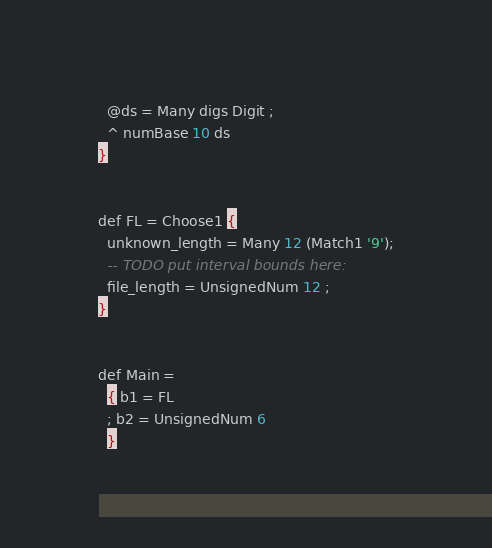<code> <loc_0><loc_0><loc_500><loc_500><_SQL_>  @ds = Many digs Digit ;
  ^ numBase 10 ds
}


def FL = Choose1 {
  unknown_length = Many 12 (Match1 '9');
  -- TODO put interval bounds here:
  file_length = UnsignedNum 12 ;
}


def Main =
  { b1 = FL
  ; b2 = UnsignedNum 6
  }
</code> 